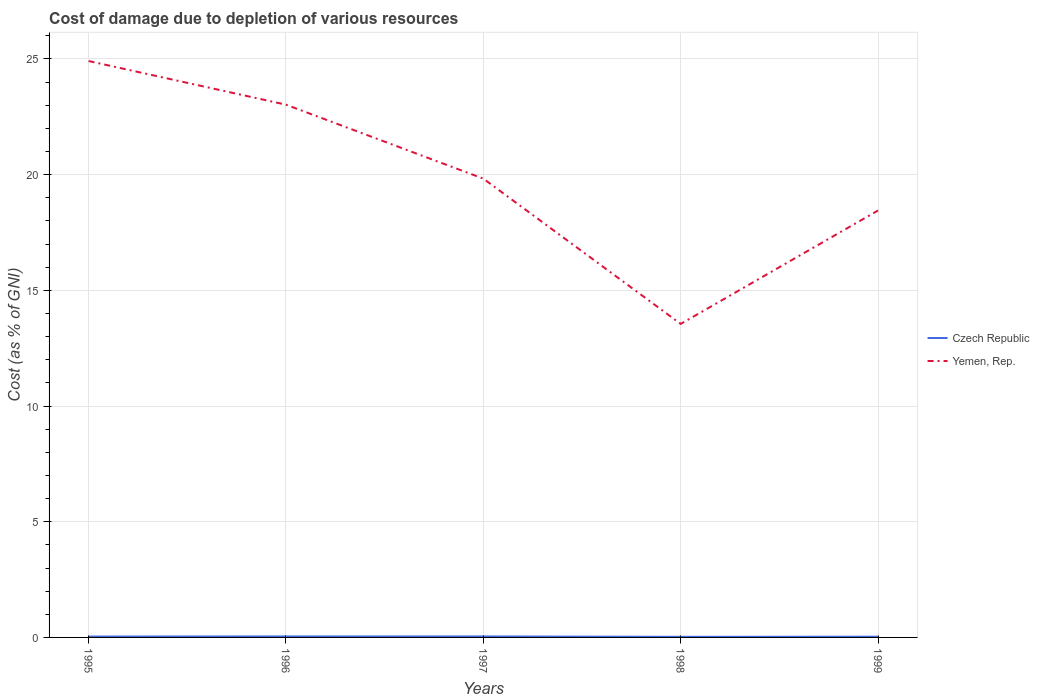How many different coloured lines are there?
Offer a terse response. 2. Is the number of lines equal to the number of legend labels?
Your answer should be compact. Yes. Across all years, what is the maximum cost of damage caused due to the depletion of various resources in Yemen, Rep.?
Provide a succinct answer. 13.55. What is the total cost of damage caused due to the depletion of various resources in Czech Republic in the graph?
Provide a succinct answer. 0.02. What is the difference between the highest and the second highest cost of damage caused due to the depletion of various resources in Yemen, Rep.?
Offer a terse response. 11.36. What is the difference between the highest and the lowest cost of damage caused due to the depletion of various resources in Czech Republic?
Provide a succinct answer. 3. Are the values on the major ticks of Y-axis written in scientific E-notation?
Offer a terse response. No. How many legend labels are there?
Your response must be concise. 2. How are the legend labels stacked?
Provide a succinct answer. Vertical. What is the title of the graph?
Ensure brevity in your answer.  Cost of damage due to depletion of various resources. Does "Philippines" appear as one of the legend labels in the graph?
Keep it short and to the point. No. What is the label or title of the Y-axis?
Give a very brief answer. Cost (as % of GNI). What is the Cost (as % of GNI) in Czech Republic in 1995?
Provide a succinct answer. 0.04. What is the Cost (as % of GNI) of Yemen, Rep. in 1995?
Make the answer very short. 24.91. What is the Cost (as % of GNI) in Czech Republic in 1996?
Your answer should be very brief. 0.04. What is the Cost (as % of GNI) in Yemen, Rep. in 1996?
Your answer should be compact. 23.02. What is the Cost (as % of GNI) of Czech Republic in 1997?
Ensure brevity in your answer.  0.04. What is the Cost (as % of GNI) of Yemen, Rep. in 1997?
Ensure brevity in your answer.  19.83. What is the Cost (as % of GNI) of Czech Republic in 1998?
Make the answer very short. 0.03. What is the Cost (as % of GNI) of Yemen, Rep. in 1998?
Offer a terse response. 13.55. What is the Cost (as % of GNI) in Czech Republic in 1999?
Ensure brevity in your answer.  0.03. What is the Cost (as % of GNI) of Yemen, Rep. in 1999?
Your answer should be compact. 18.45. Across all years, what is the maximum Cost (as % of GNI) of Czech Republic?
Offer a terse response. 0.04. Across all years, what is the maximum Cost (as % of GNI) of Yemen, Rep.?
Ensure brevity in your answer.  24.91. Across all years, what is the minimum Cost (as % of GNI) in Czech Republic?
Your answer should be compact. 0.03. Across all years, what is the minimum Cost (as % of GNI) of Yemen, Rep.?
Your answer should be compact. 13.55. What is the total Cost (as % of GNI) of Czech Republic in the graph?
Provide a short and direct response. 0.18. What is the total Cost (as % of GNI) of Yemen, Rep. in the graph?
Keep it short and to the point. 99.76. What is the difference between the Cost (as % of GNI) of Czech Republic in 1995 and that in 1996?
Your answer should be very brief. -0.01. What is the difference between the Cost (as % of GNI) of Yemen, Rep. in 1995 and that in 1996?
Provide a short and direct response. 1.89. What is the difference between the Cost (as % of GNI) of Czech Republic in 1995 and that in 1997?
Offer a very short reply. -0.01. What is the difference between the Cost (as % of GNI) of Yemen, Rep. in 1995 and that in 1997?
Keep it short and to the point. 5.08. What is the difference between the Cost (as % of GNI) in Czech Republic in 1995 and that in 1998?
Provide a short and direct response. 0.01. What is the difference between the Cost (as % of GNI) in Yemen, Rep. in 1995 and that in 1998?
Give a very brief answer. 11.36. What is the difference between the Cost (as % of GNI) of Czech Republic in 1995 and that in 1999?
Keep it short and to the point. 0.01. What is the difference between the Cost (as % of GNI) in Yemen, Rep. in 1995 and that in 1999?
Make the answer very short. 6.46. What is the difference between the Cost (as % of GNI) of Czech Republic in 1996 and that in 1997?
Your answer should be very brief. 0. What is the difference between the Cost (as % of GNI) in Yemen, Rep. in 1996 and that in 1997?
Ensure brevity in your answer.  3.2. What is the difference between the Cost (as % of GNI) in Czech Republic in 1996 and that in 1998?
Offer a terse response. 0.02. What is the difference between the Cost (as % of GNI) of Yemen, Rep. in 1996 and that in 1998?
Offer a terse response. 9.47. What is the difference between the Cost (as % of GNI) of Czech Republic in 1996 and that in 1999?
Your answer should be very brief. 0.01. What is the difference between the Cost (as % of GNI) of Yemen, Rep. in 1996 and that in 1999?
Offer a terse response. 4.57. What is the difference between the Cost (as % of GNI) in Czech Republic in 1997 and that in 1998?
Keep it short and to the point. 0.02. What is the difference between the Cost (as % of GNI) of Yemen, Rep. in 1997 and that in 1998?
Offer a terse response. 6.28. What is the difference between the Cost (as % of GNI) in Czech Republic in 1997 and that in 1999?
Provide a succinct answer. 0.01. What is the difference between the Cost (as % of GNI) in Yemen, Rep. in 1997 and that in 1999?
Provide a succinct answer. 1.38. What is the difference between the Cost (as % of GNI) in Czech Republic in 1998 and that in 1999?
Provide a succinct answer. -0. What is the difference between the Cost (as % of GNI) of Yemen, Rep. in 1998 and that in 1999?
Provide a short and direct response. -4.9. What is the difference between the Cost (as % of GNI) in Czech Republic in 1995 and the Cost (as % of GNI) in Yemen, Rep. in 1996?
Your answer should be very brief. -22.99. What is the difference between the Cost (as % of GNI) of Czech Republic in 1995 and the Cost (as % of GNI) of Yemen, Rep. in 1997?
Offer a very short reply. -19.79. What is the difference between the Cost (as % of GNI) in Czech Republic in 1995 and the Cost (as % of GNI) in Yemen, Rep. in 1998?
Offer a terse response. -13.51. What is the difference between the Cost (as % of GNI) in Czech Republic in 1995 and the Cost (as % of GNI) in Yemen, Rep. in 1999?
Provide a short and direct response. -18.41. What is the difference between the Cost (as % of GNI) in Czech Republic in 1996 and the Cost (as % of GNI) in Yemen, Rep. in 1997?
Give a very brief answer. -19.78. What is the difference between the Cost (as % of GNI) of Czech Republic in 1996 and the Cost (as % of GNI) of Yemen, Rep. in 1998?
Ensure brevity in your answer.  -13.51. What is the difference between the Cost (as % of GNI) of Czech Republic in 1996 and the Cost (as % of GNI) of Yemen, Rep. in 1999?
Your answer should be very brief. -18.41. What is the difference between the Cost (as % of GNI) in Czech Republic in 1997 and the Cost (as % of GNI) in Yemen, Rep. in 1998?
Give a very brief answer. -13.51. What is the difference between the Cost (as % of GNI) in Czech Republic in 1997 and the Cost (as % of GNI) in Yemen, Rep. in 1999?
Your answer should be compact. -18.41. What is the difference between the Cost (as % of GNI) in Czech Republic in 1998 and the Cost (as % of GNI) in Yemen, Rep. in 1999?
Make the answer very short. -18.42. What is the average Cost (as % of GNI) of Czech Republic per year?
Offer a terse response. 0.04. What is the average Cost (as % of GNI) in Yemen, Rep. per year?
Give a very brief answer. 19.95. In the year 1995, what is the difference between the Cost (as % of GNI) of Czech Republic and Cost (as % of GNI) of Yemen, Rep.?
Your answer should be compact. -24.87. In the year 1996, what is the difference between the Cost (as % of GNI) in Czech Republic and Cost (as % of GNI) in Yemen, Rep.?
Offer a terse response. -22.98. In the year 1997, what is the difference between the Cost (as % of GNI) of Czech Republic and Cost (as % of GNI) of Yemen, Rep.?
Ensure brevity in your answer.  -19.78. In the year 1998, what is the difference between the Cost (as % of GNI) in Czech Republic and Cost (as % of GNI) in Yemen, Rep.?
Ensure brevity in your answer.  -13.52. In the year 1999, what is the difference between the Cost (as % of GNI) in Czech Republic and Cost (as % of GNI) in Yemen, Rep.?
Offer a terse response. -18.42. What is the ratio of the Cost (as % of GNI) in Czech Republic in 1995 to that in 1996?
Your answer should be compact. 0.87. What is the ratio of the Cost (as % of GNI) of Yemen, Rep. in 1995 to that in 1996?
Provide a short and direct response. 1.08. What is the ratio of the Cost (as % of GNI) of Czech Republic in 1995 to that in 1997?
Your answer should be compact. 0.88. What is the ratio of the Cost (as % of GNI) of Yemen, Rep. in 1995 to that in 1997?
Offer a very short reply. 1.26. What is the ratio of the Cost (as % of GNI) in Czech Republic in 1995 to that in 1998?
Provide a succinct answer. 1.39. What is the ratio of the Cost (as % of GNI) in Yemen, Rep. in 1995 to that in 1998?
Offer a terse response. 1.84. What is the ratio of the Cost (as % of GNI) of Czech Republic in 1995 to that in 1999?
Your answer should be compact. 1.19. What is the ratio of the Cost (as % of GNI) of Yemen, Rep. in 1995 to that in 1999?
Offer a terse response. 1.35. What is the ratio of the Cost (as % of GNI) in Czech Republic in 1996 to that in 1997?
Ensure brevity in your answer.  1.01. What is the ratio of the Cost (as % of GNI) in Yemen, Rep. in 1996 to that in 1997?
Offer a very short reply. 1.16. What is the ratio of the Cost (as % of GNI) of Czech Republic in 1996 to that in 1998?
Give a very brief answer. 1.59. What is the ratio of the Cost (as % of GNI) of Yemen, Rep. in 1996 to that in 1998?
Your answer should be compact. 1.7. What is the ratio of the Cost (as % of GNI) in Czech Republic in 1996 to that in 1999?
Keep it short and to the point. 1.36. What is the ratio of the Cost (as % of GNI) in Yemen, Rep. in 1996 to that in 1999?
Your answer should be very brief. 1.25. What is the ratio of the Cost (as % of GNI) in Czech Republic in 1997 to that in 1998?
Your answer should be very brief. 1.58. What is the ratio of the Cost (as % of GNI) of Yemen, Rep. in 1997 to that in 1998?
Provide a short and direct response. 1.46. What is the ratio of the Cost (as % of GNI) of Czech Republic in 1997 to that in 1999?
Your response must be concise. 1.35. What is the ratio of the Cost (as % of GNI) in Yemen, Rep. in 1997 to that in 1999?
Offer a very short reply. 1.07. What is the ratio of the Cost (as % of GNI) in Czech Republic in 1998 to that in 1999?
Make the answer very short. 0.85. What is the ratio of the Cost (as % of GNI) in Yemen, Rep. in 1998 to that in 1999?
Provide a succinct answer. 0.73. What is the difference between the highest and the second highest Cost (as % of GNI) of Czech Republic?
Your answer should be very brief. 0. What is the difference between the highest and the second highest Cost (as % of GNI) of Yemen, Rep.?
Make the answer very short. 1.89. What is the difference between the highest and the lowest Cost (as % of GNI) in Czech Republic?
Offer a very short reply. 0.02. What is the difference between the highest and the lowest Cost (as % of GNI) of Yemen, Rep.?
Provide a succinct answer. 11.36. 